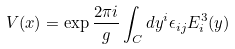Convert formula to latex. <formula><loc_0><loc_0><loc_500><loc_500>V ( x ) = \exp { \frac { 2 \pi i } { g } } \int _ { C } d y ^ { i } \epsilon _ { i j } E _ { i } ^ { 3 } ( y )</formula> 